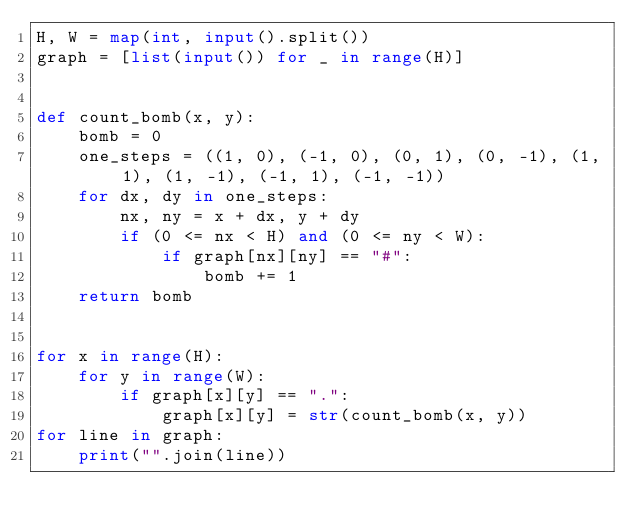<code> <loc_0><loc_0><loc_500><loc_500><_Python_>H, W = map(int, input().split())
graph = [list(input()) for _ in range(H)]


def count_bomb(x, y):
    bomb = 0
    one_steps = ((1, 0), (-1, 0), (0, 1), (0, -1), (1, 1), (1, -1), (-1, 1), (-1, -1))
    for dx, dy in one_steps:
        nx, ny = x + dx, y + dy
        if (0 <= nx < H) and (0 <= ny < W):
            if graph[nx][ny] == "#":
                bomb += 1
    return bomb


for x in range(H):
    for y in range(W):
        if graph[x][y] == ".":
            graph[x][y] = str(count_bomb(x, y))
for line in graph:
    print("".join(line))
</code> 